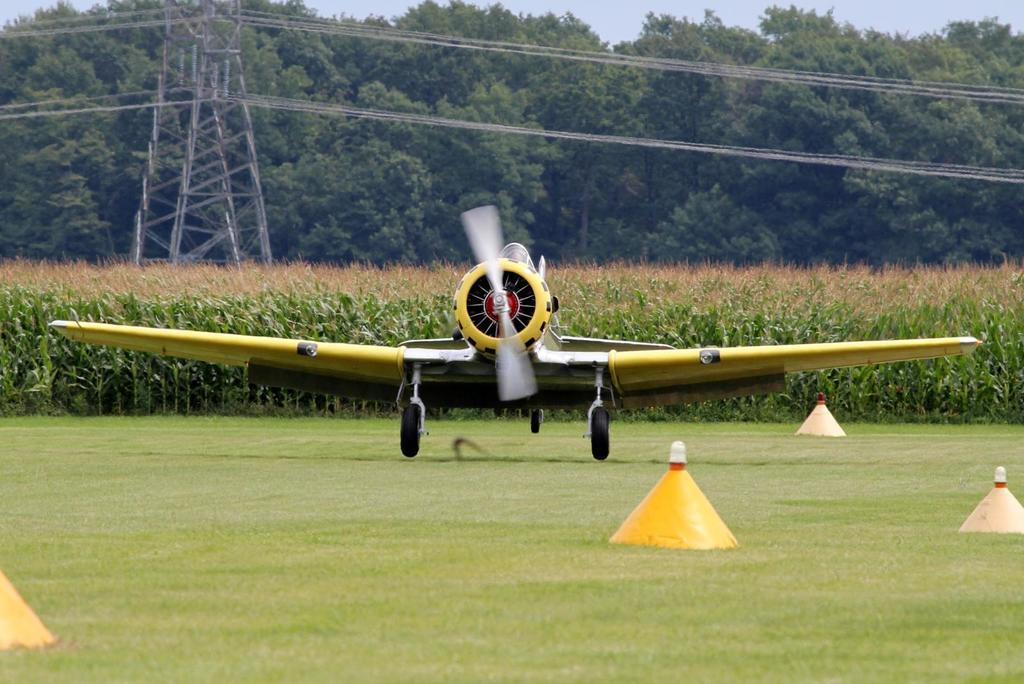What is the main subject of the image? The main subject of the image is an airplane on the ground. What else can be seen on the ground in the image? There are objects on the ground in the image. What type of vegetation is visible in the background of the image? There are plants and trees in the background of the image. What structures can be seen in the background of the image? There is a tower with wires in the background of the image. What is visible in the sky in the image? The sky is visible in the background of the image. What is the temper of the airplane in the image? The airplane does not have a temper, as it is an inanimate object. 